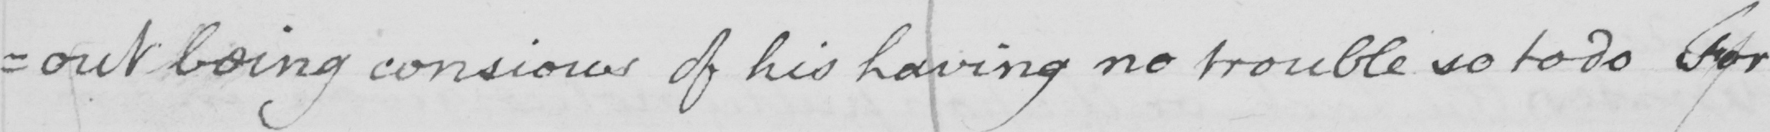Can you read and transcribe this handwriting? =out being conscious of his having no trouble so to do for 